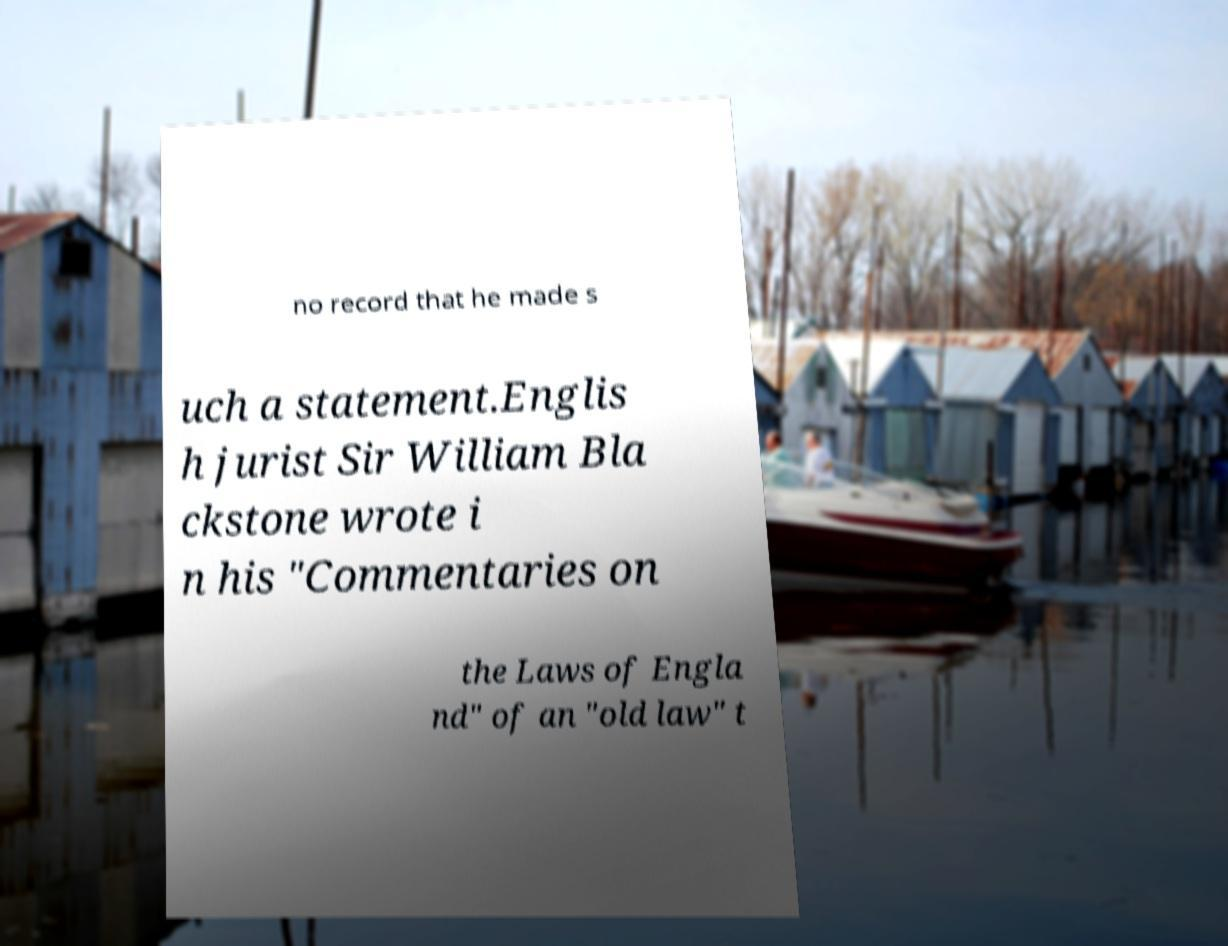There's text embedded in this image that I need extracted. Can you transcribe it verbatim? no record that he made s uch a statement.Englis h jurist Sir William Bla ckstone wrote i n his "Commentaries on the Laws of Engla nd" of an "old law" t 